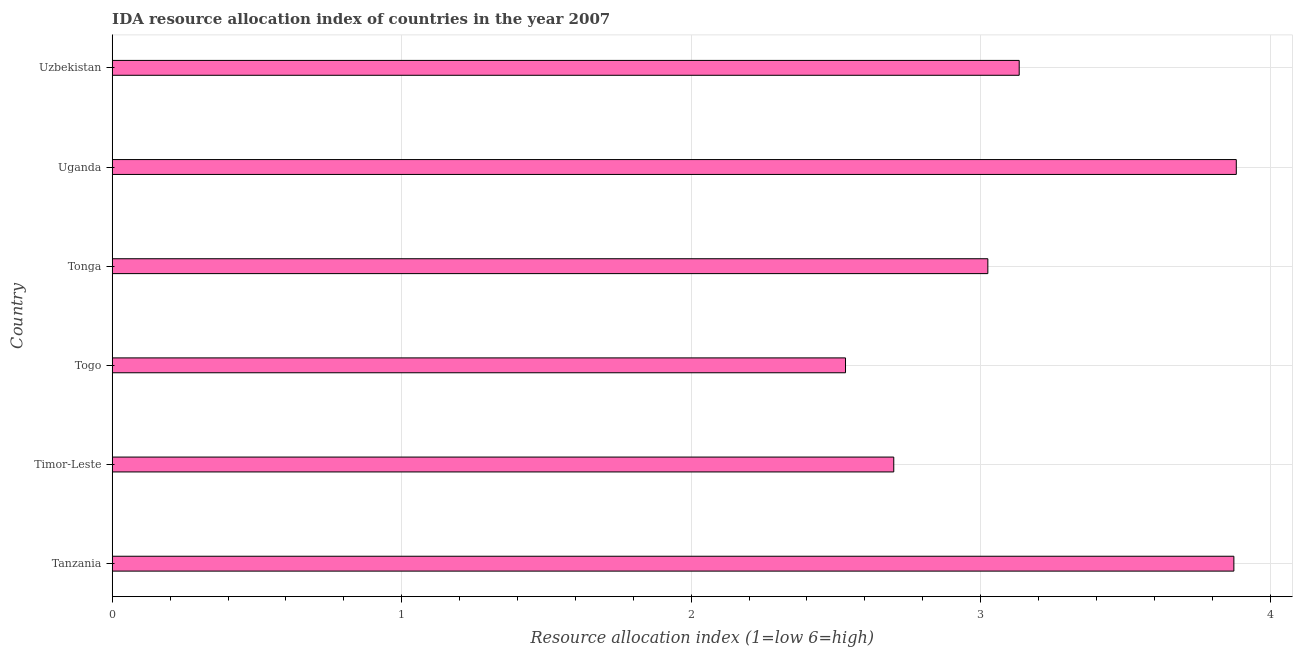Does the graph contain grids?
Make the answer very short. Yes. What is the title of the graph?
Your response must be concise. IDA resource allocation index of countries in the year 2007. What is the label or title of the X-axis?
Ensure brevity in your answer.  Resource allocation index (1=low 6=high). What is the label or title of the Y-axis?
Your response must be concise. Country. What is the ida resource allocation index in Uzbekistan?
Your response must be concise. 3.13. Across all countries, what is the maximum ida resource allocation index?
Offer a terse response. 3.88. Across all countries, what is the minimum ida resource allocation index?
Give a very brief answer. 2.53. In which country was the ida resource allocation index maximum?
Offer a terse response. Uganda. In which country was the ida resource allocation index minimum?
Provide a succinct answer. Togo. What is the sum of the ida resource allocation index?
Ensure brevity in your answer.  19.15. What is the difference between the ida resource allocation index in Togo and Tonga?
Provide a short and direct response. -0.49. What is the average ida resource allocation index per country?
Ensure brevity in your answer.  3.19. What is the median ida resource allocation index?
Your answer should be compact. 3.08. What is the ratio of the ida resource allocation index in Togo to that in Uganda?
Your answer should be very brief. 0.65. What is the difference between the highest and the second highest ida resource allocation index?
Ensure brevity in your answer.  0.01. Is the sum of the ida resource allocation index in Togo and Uganda greater than the maximum ida resource allocation index across all countries?
Your answer should be compact. Yes. What is the difference between the highest and the lowest ida resource allocation index?
Give a very brief answer. 1.35. How many bars are there?
Make the answer very short. 6. Are the values on the major ticks of X-axis written in scientific E-notation?
Give a very brief answer. No. What is the Resource allocation index (1=low 6=high) in Tanzania?
Your response must be concise. 3.88. What is the Resource allocation index (1=low 6=high) of Togo?
Make the answer very short. 2.53. What is the Resource allocation index (1=low 6=high) in Tonga?
Give a very brief answer. 3.02. What is the Resource allocation index (1=low 6=high) in Uganda?
Your response must be concise. 3.88. What is the Resource allocation index (1=low 6=high) in Uzbekistan?
Offer a very short reply. 3.13. What is the difference between the Resource allocation index (1=low 6=high) in Tanzania and Timor-Leste?
Offer a terse response. 1.18. What is the difference between the Resource allocation index (1=low 6=high) in Tanzania and Togo?
Provide a short and direct response. 1.34. What is the difference between the Resource allocation index (1=low 6=high) in Tanzania and Tonga?
Keep it short and to the point. 0.85. What is the difference between the Resource allocation index (1=low 6=high) in Tanzania and Uganda?
Provide a short and direct response. -0.01. What is the difference between the Resource allocation index (1=low 6=high) in Tanzania and Uzbekistan?
Ensure brevity in your answer.  0.74. What is the difference between the Resource allocation index (1=low 6=high) in Timor-Leste and Togo?
Offer a terse response. 0.17. What is the difference between the Resource allocation index (1=low 6=high) in Timor-Leste and Tonga?
Make the answer very short. -0.33. What is the difference between the Resource allocation index (1=low 6=high) in Timor-Leste and Uganda?
Your answer should be very brief. -1.18. What is the difference between the Resource allocation index (1=low 6=high) in Timor-Leste and Uzbekistan?
Your answer should be very brief. -0.43. What is the difference between the Resource allocation index (1=low 6=high) in Togo and Tonga?
Your answer should be compact. -0.49. What is the difference between the Resource allocation index (1=low 6=high) in Togo and Uganda?
Provide a succinct answer. -1.35. What is the difference between the Resource allocation index (1=low 6=high) in Tonga and Uganda?
Provide a succinct answer. -0.86. What is the difference between the Resource allocation index (1=low 6=high) in Tonga and Uzbekistan?
Provide a succinct answer. -0.11. What is the ratio of the Resource allocation index (1=low 6=high) in Tanzania to that in Timor-Leste?
Your response must be concise. 1.44. What is the ratio of the Resource allocation index (1=low 6=high) in Tanzania to that in Togo?
Make the answer very short. 1.53. What is the ratio of the Resource allocation index (1=low 6=high) in Tanzania to that in Tonga?
Provide a short and direct response. 1.28. What is the ratio of the Resource allocation index (1=low 6=high) in Tanzania to that in Uzbekistan?
Your response must be concise. 1.24. What is the ratio of the Resource allocation index (1=low 6=high) in Timor-Leste to that in Togo?
Give a very brief answer. 1.07. What is the ratio of the Resource allocation index (1=low 6=high) in Timor-Leste to that in Tonga?
Offer a terse response. 0.89. What is the ratio of the Resource allocation index (1=low 6=high) in Timor-Leste to that in Uganda?
Ensure brevity in your answer.  0.69. What is the ratio of the Resource allocation index (1=low 6=high) in Timor-Leste to that in Uzbekistan?
Provide a short and direct response. 0.86. What is the ratio of the Resource allocation index (1=low 6=high) in Togo to that in Tonga?
Offer a very short reply. 0.84. What is the ratio of the Resource allocation index (1=low 6=high) in Togo to that in Uganda?
Your response must be concise. 0.65. What is the ratio of the Resource allocation index (1=low 6=high) in Togo to that in Uzbekistan?
Keep it short and to the point. 0.81. What is the ratio of the Resource allocation index (1=low 6=high) in Tonga to that in Uganda?
Your response must be concise. 0.78. What is the ratio of the Resource allocation index (1=low 6=high) in Uganda to that in Uzbekistan?
Provide a short and direct response. 1.24. 